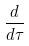<formula> <loc_0><loc_0><loc_500><loc_500>\frac { d } { d \tau }</formula> 